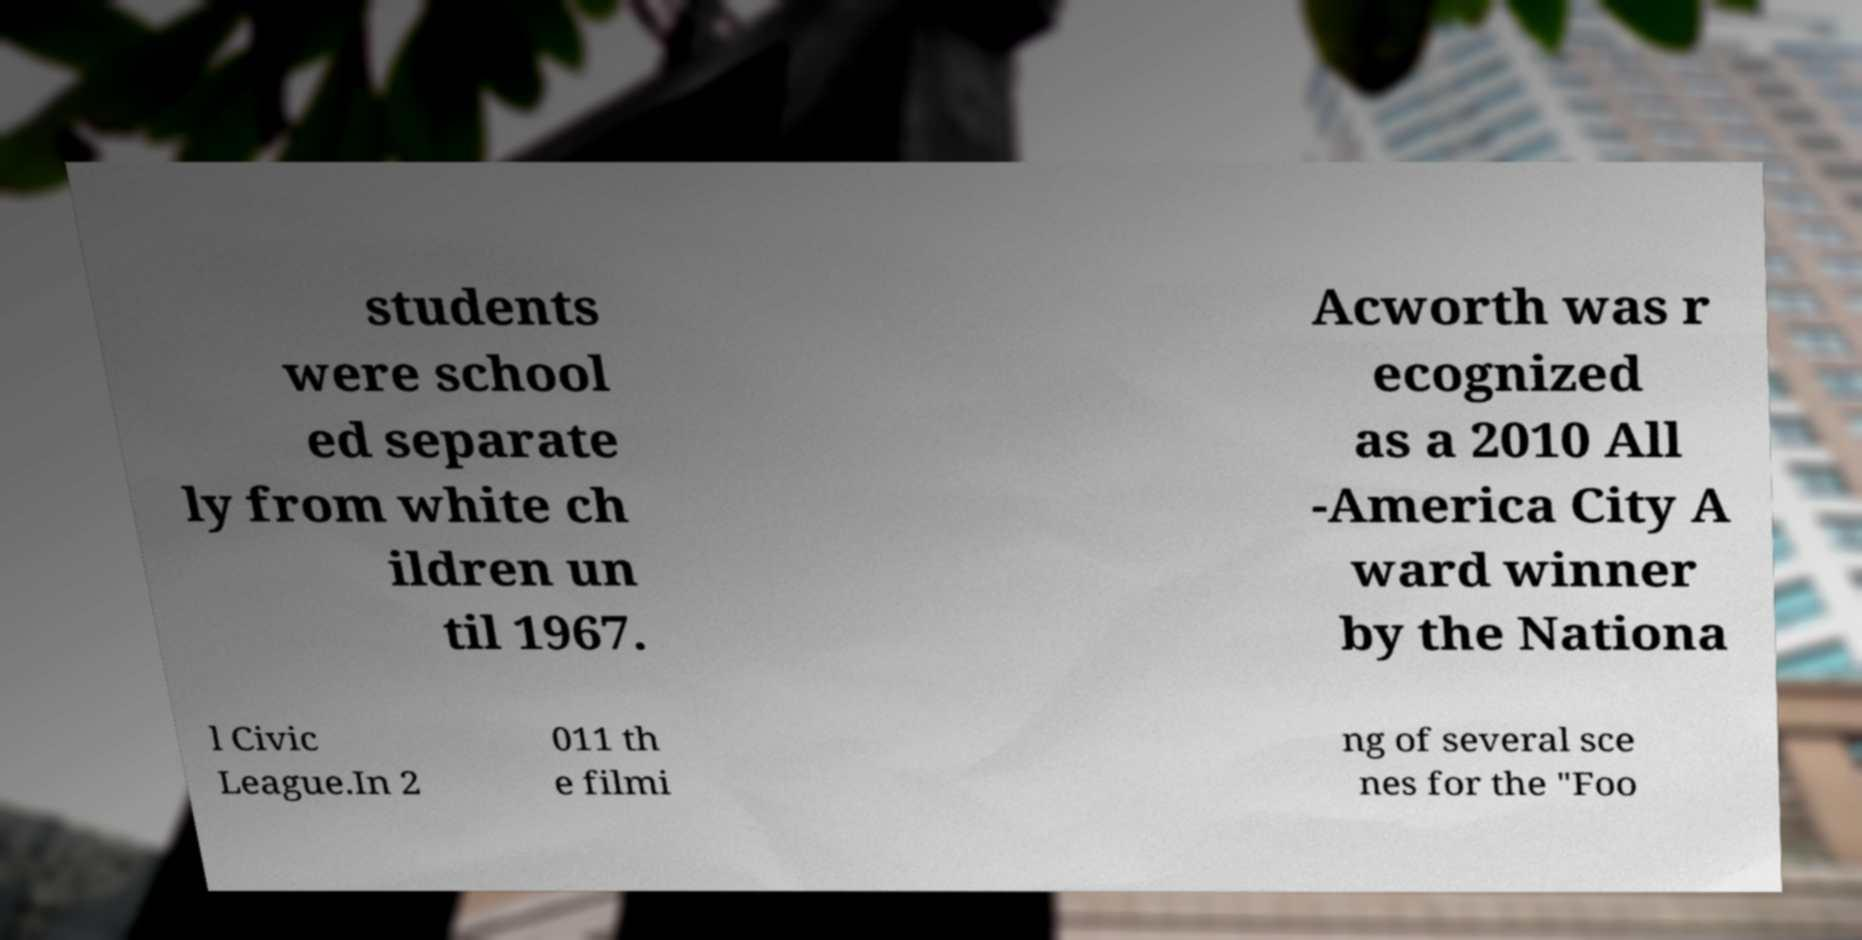Could you assist in decoding the text presented in this image and type it out clearly? students were school ed separate ly from white ch ildren un til 1967. Acworth was r ecognized as a 2010 All -America City A ward winner by the Nationa l Civic League.In 2 011 th e filmi ng of several sce nes for the "Foo 